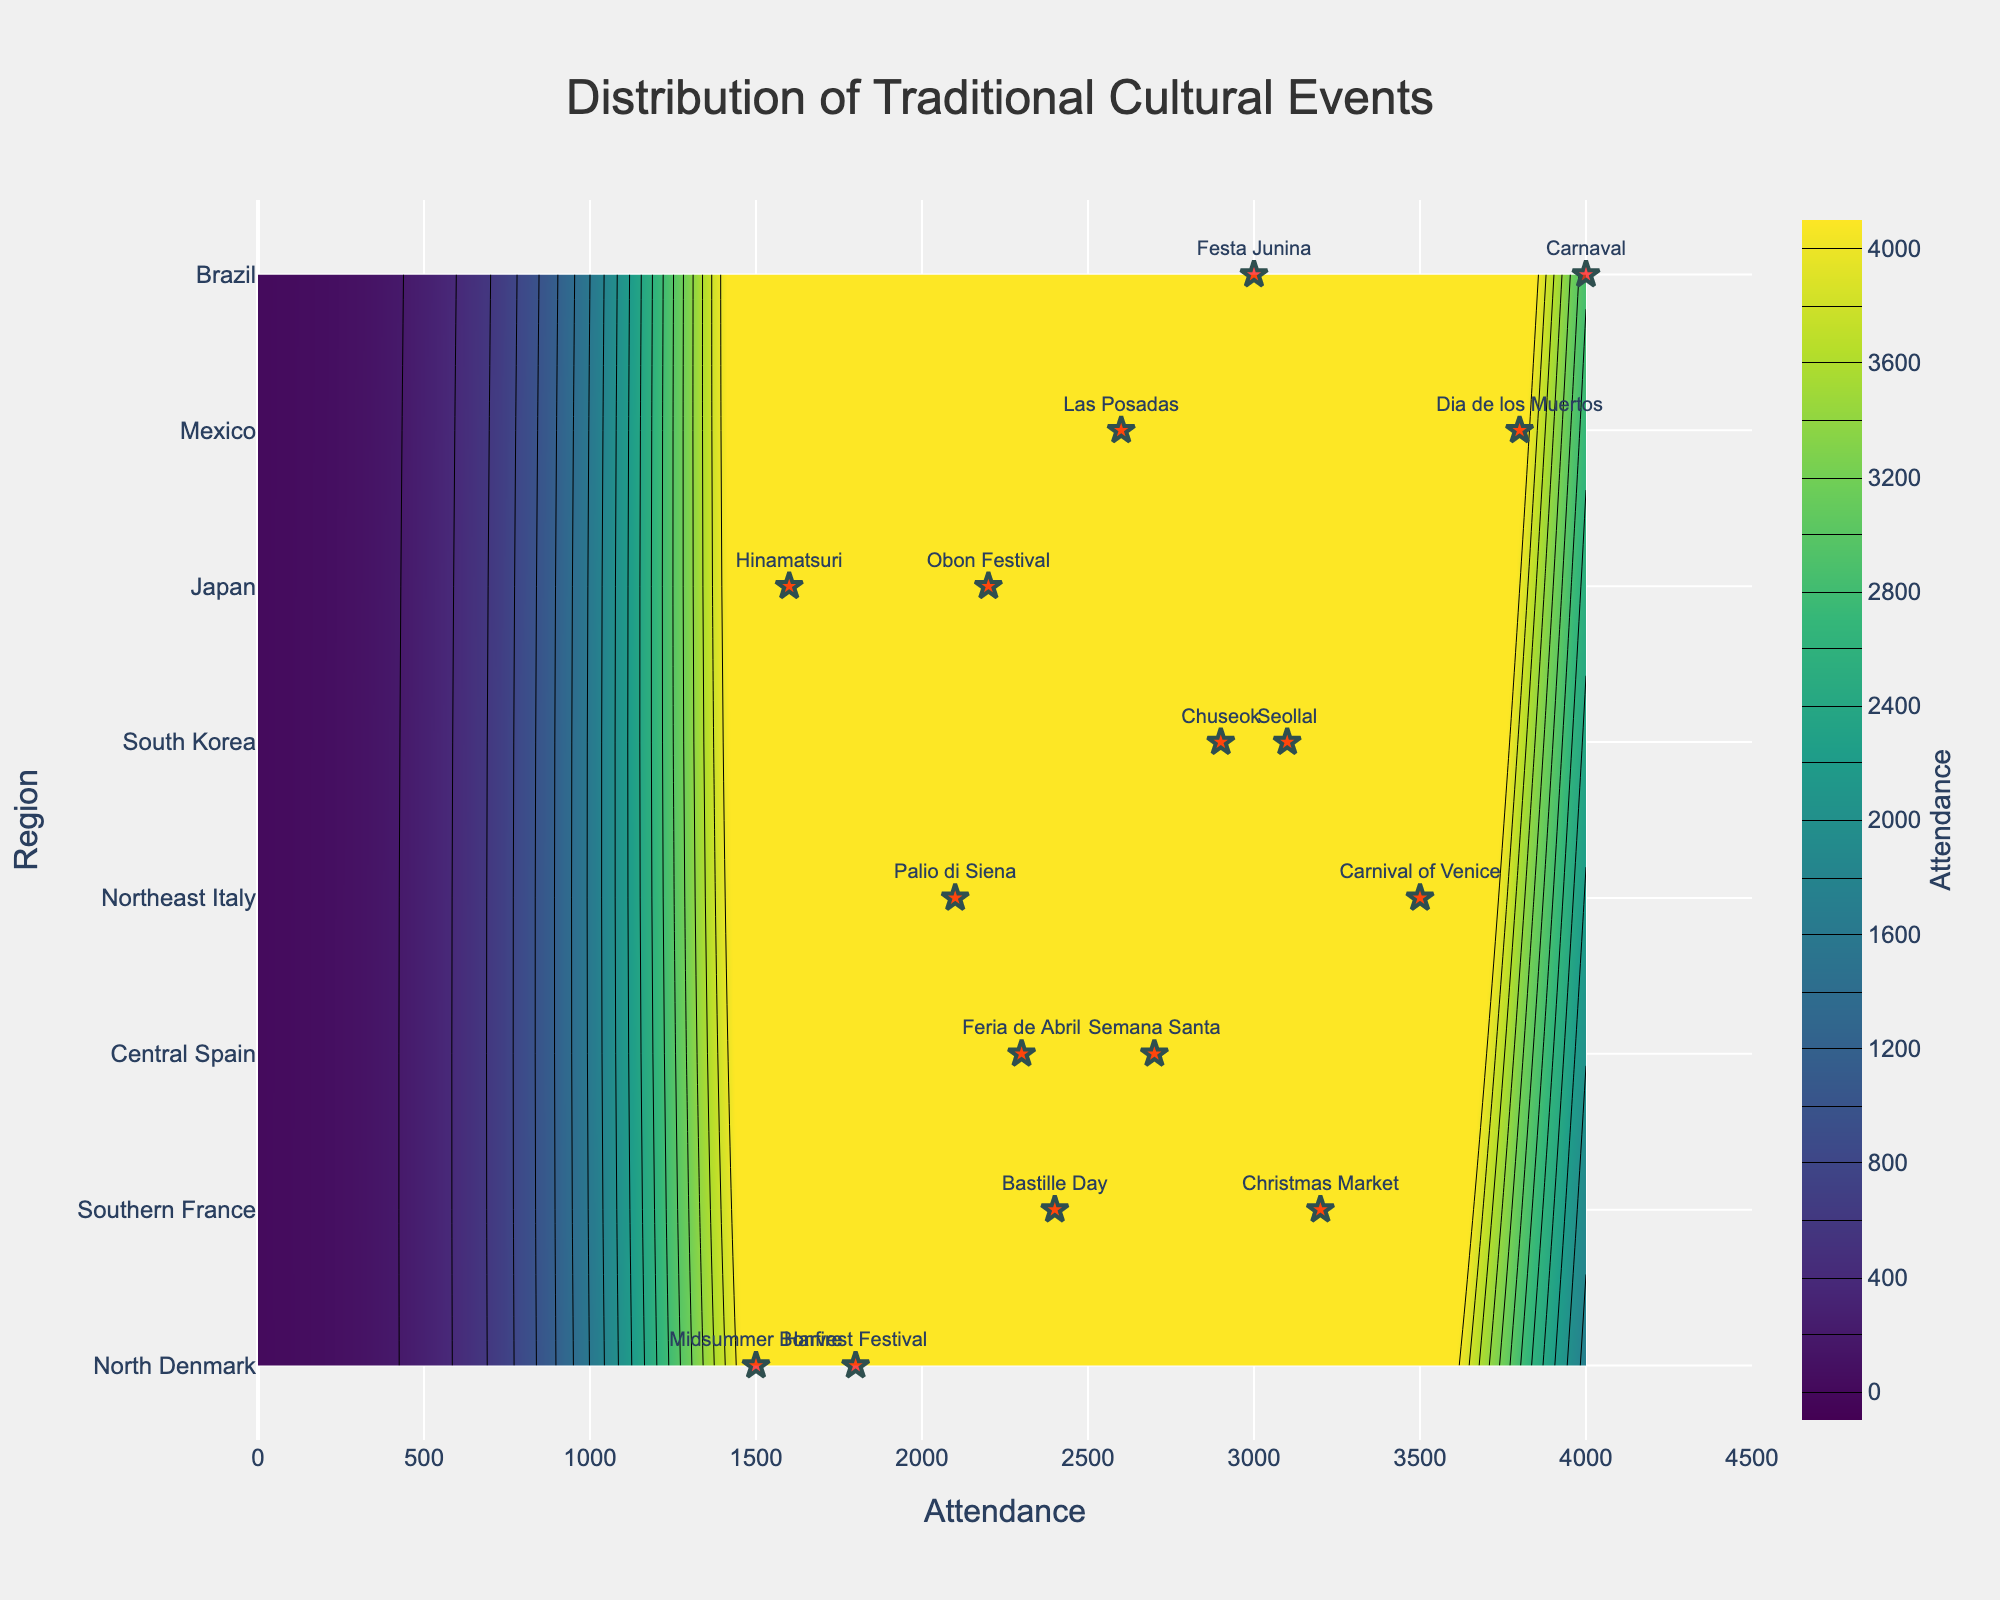What's the title of the plot? The title is at the top and is clearly visible, indicating the main subject of the plot.
Answer: Distribution of Traditional Cultural Events Which region has the highest single event attendance? By looking at the highest point in the contour lines or the scatter event markers, identify the largest value along the attendance axis.
Answer: Brazil How is the attendance distributed across regions? By observing the contours and their density/intensity across different regions, note the variations in attendance values. The denser the contours, the higher the concentration of attendance.
Answer: Varies, with high density in Brazil and Mexico Which event drew the largest attendance in Brazil? By identifying the events in Brazil along with their corresponding attendance values, determine which one is larger.
Answer: Carnaval If you sum the attendances of the two events with the highest attendance, what is the total? Identify the top two events with the highest attendance and add their values. Carnaval in Brazil (4000) and Dia de los Muertos in Mexico (3800). Their total is 7800.
Answer: 7800 Which regions have events with more than 3000 attendees? By locating regions with events marked over the 3000 attendance line, list those regions.
Answer: Southern France, Northeast Italy, South Korea, Brazil How does the attendance for the Harvest Festival in North Denmark compare to that for the Christmas Market in Southern France? Compare the attendance values of Harvest Festival (1800) and Christmas Market (3200). Harvest Festival has lower attendance.
Answer: Harvest Festival is lower What can be inferred about the cultural significance of events in Northeast Italy compared to Central Spain based on attendance? Compare the general attendance density and peaks in both regions. Northeast Italy has high attendance at events like Carnival of Venice, suggesting high cultural significance.
Answer: Higher attendance in Northeast Italy What is the range of attendance values on the x-axis? Look at the minimum and maximum values indicated on the x-axis of the plot.
Answer: 0 to 4500 Which event in South Korea has the highest attendance? Locate South Korean events on the plot along with their attendance values and find the highest one.
Answer: Seollal 